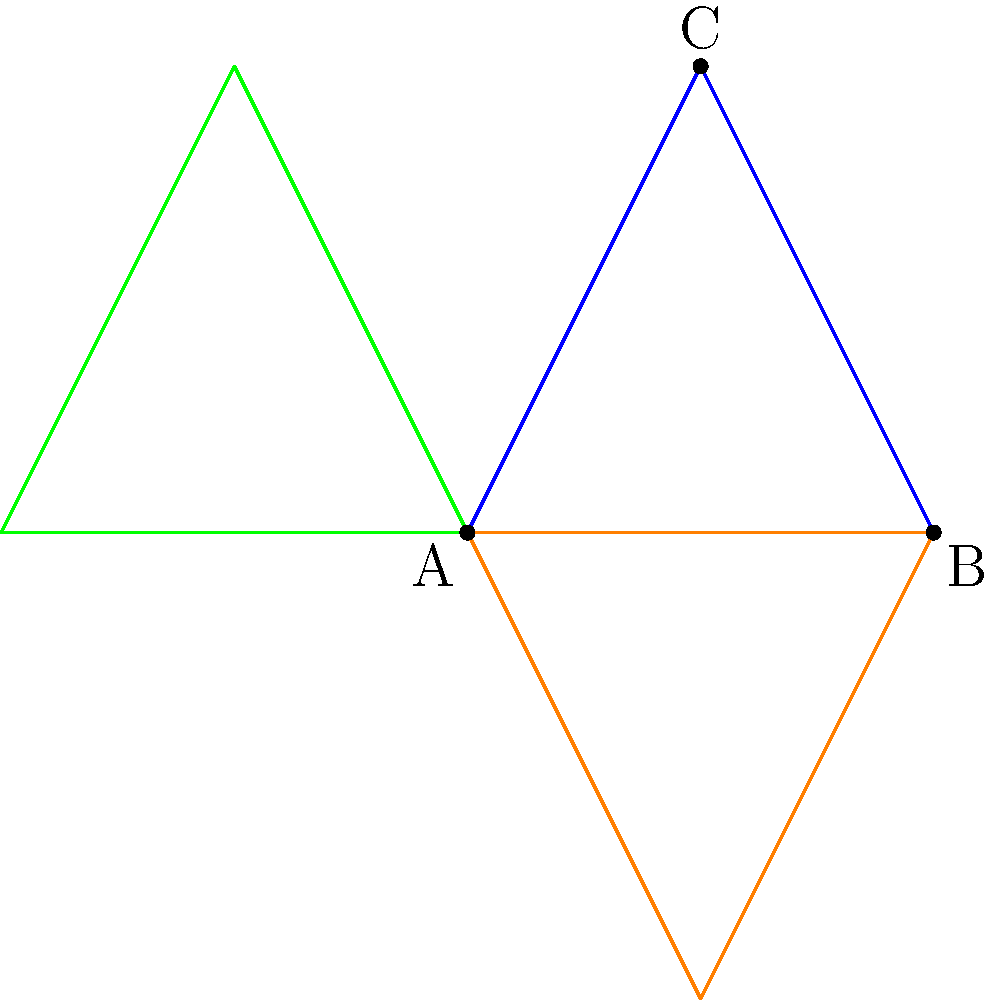For an eye-catching web banner design, you've created a custom triangle ABC and reflected it across multiple axes. If the original triangle has coordinates A(0,0), B(2,0), and C(1,2), how many unique triangles (including the original) will appear in the final symmetrical design when reflecting across both the x-axis and y-axis? To determine the number of unique triangles in the final symmetrical design, let's follow these steps:

1. Start with the original triangle ABC (blue in the diagram).

2. Reflect across the x-axis (y = 0):
   - This creates a new triangle below the x-axis (red in the diagram).

3. Reflect across the y-axis (x = 0):
   - The original triangle (blue) reflects to create a new triangle on the left side of the y-axis.
   - The triangle created in step 2 (red) also reflects across the y-axis, creating another new triangle.

4. Count the unique triangles:
   - Original triangle (blue)
   - Reflection across x-axis (red)
   - Reflection of blue across y-axis
   - Reflection of red across y-axis

Therefore, the final symmetrical design will contain 4 unique triangles.

This reflection process creates a visually balanced and symmetrical web banner design, which is perfect for capturing audience attention in digital media.
Answer: 4 unique triangles 